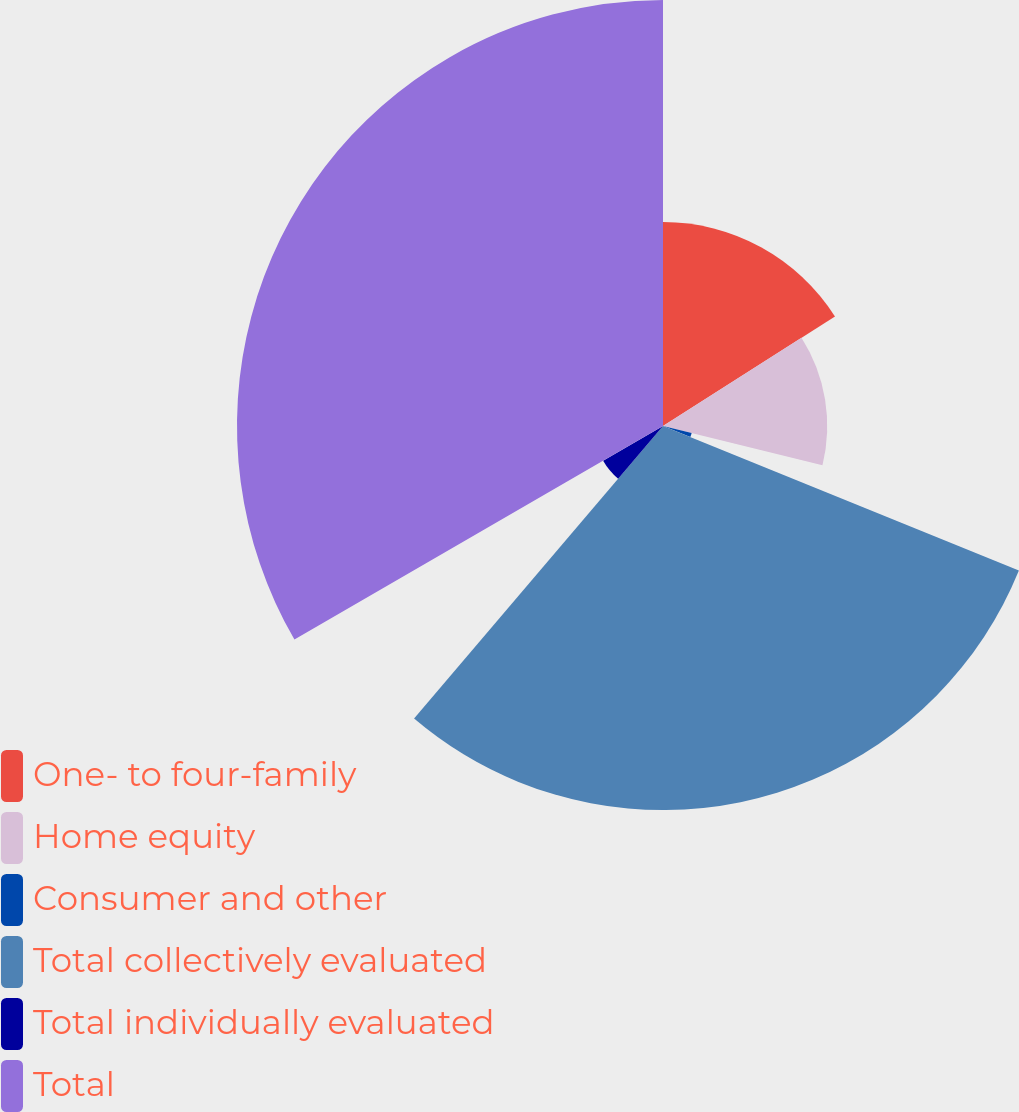Convert chart. <chart><loc_0><loc_0><loc_500><loc_500><pie_chart><fcel>One- to four-family<fcel>Home equity<fcel>Consumer and other<fcel>Total collectively evaluated<fcel>Total individually evaluated<fcel>Total<nl><fcel>15.97%<fcel>12.86%<fcel>2.31%<fcel>30.08%<fcel>5.42%<fcel>33.36%<nl></chart> 